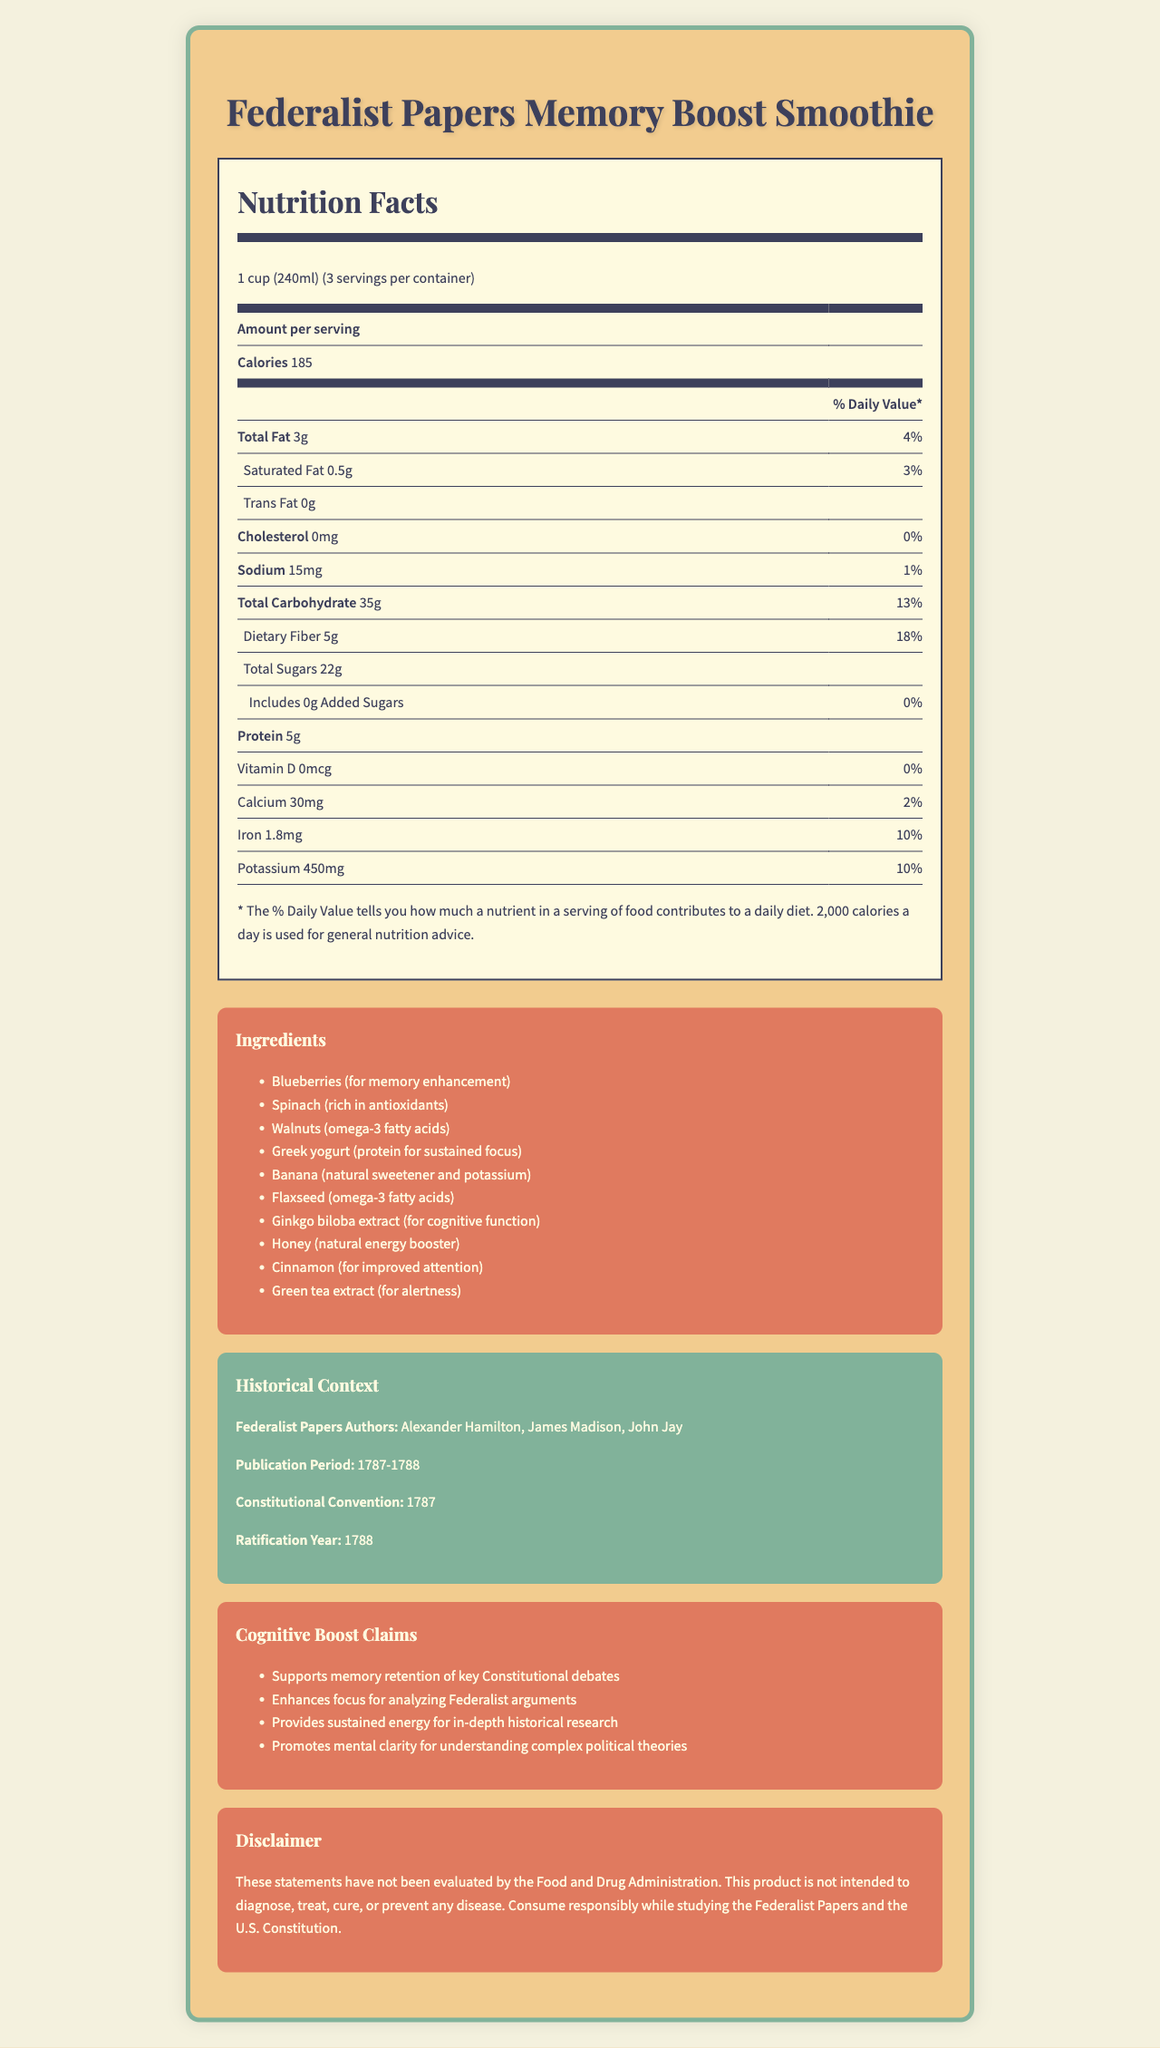what is the serving size for the Federalist Papers Memory Boost Smoothie? The serving size is mentioned at the beginning of the nutrition label.
Answer: 1 cup (240ml) how many servings are there per container? The document states that there are 3 servings per container.
Answer: 3 what is the amount of dietary fiber per serving? The dietary fiber content per serving is listed as 5g.
Answer: 5g list two ingredients that are included for their cognitive function benefits. Ginkgo biloba extract is included for cognitive function, and Green tea extract for alertness.
Answer: Ginkgo biloba extract, Green tea extract who were the authors of the Federalist Papers? The historical context section lists the authors of the Federalist Papers as Alexander Hamilton, James Madison, and John Jay.
Answer: Alexander Hamilton, James Madison, John Jay what is the percentage daily value of calcium per serving? The percentage daily value of calcium per serving is shown as 2%.
Answer: 2% does the Federalist Papers Memory Boost Smoothie contain any trans fat? The nutrition facts section shows that the amount of trans fat is 0g.
Answer: No which ingredient provides natural sweetness and potassium? A. Walnuts B. Blueberries C. Banana D. Honey The ingredients list mentions Banana as a natural sweetener and a source of potassium.
Answer: C. Banana how many calories are in one serving of the smoothie? A. 100 B. 185 C. 250 D. 300 The calories per serving are listed as 185 on the nutrition label.
Answer: B. 185 what is the publication period of the Federalist Papers? The historical context section states that the publication period was from 1787 to 1788.
Answer: 1787-1788 what is the total amount of sugars per serving? The document specifies that the total sugars per serving is 22g.
Answer: 22g does the Federalist Papers Memory Boost Smoothie include added sugars? The nutrition facts state that the amount of added sugars is 0g.
Answer: No identify one claim about the cognitive benefits of the smoothie. One of the cognitive boost claims listed is "Supports memory retention of key Constitutional debates".
Answer: Supports memory retention of key Constitutional debates true or false: the product claims have been evaluated by the Food and Drug Administration. The disclaimer clearly states that these claims have not been evaluated by the FDA.
Answer: False how much protein does each serving of the smoothie contain? The protein content per serving is listed as 5g.
Answer: 5g summarize the main idea of the document. The document provides comprehensive information about the smoothie, including its nutritional content, ingredients designed to boost cognitive function, the historical significance of the Federalist Papers, and specific claims about the product's benefits.
Answer: The document details the nutrition facts, ingredients, historical context, and cognitive benefit claims for the "Federalist Papers Memory Boost Smoothie", which includes various ingredients aimed at enhancing memory, concentration, and mental clarity. It also emphasizes the connection to the Federalist Papers and its authors. what are the potential side effects of the ingredients in the smoothie? The document does not provide any information about potential side effects of the ingredients.
Answer: Not enough information 